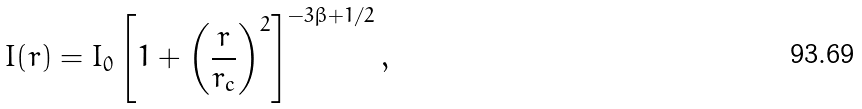Convert formula to latex. <formula><loc_0><loc_0><loc_500><loc_500>I ( r ) = I _ { 0 } \left [ 1 + \left ( \frac { r } { r _ { c } } \right ) ^ { 2 } \right ] ^ { - 3 \beta + 1 / 2 } ,</formula> 